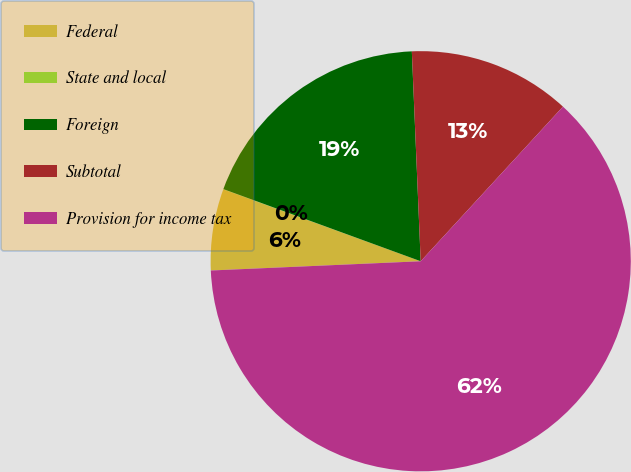Convert chart. <chart><loc_0><loc_0><loc_500><loc_500><pie_chart><fcel>Federal<fcel>State and local<fcel>Foreign<fcel>Subtotal<fcel>Provision for income tax<nl><fcel>6.26%<fcel>0.02%<fcel>18.75%<fcel>12.51%<fcel>62.46%<nl></chart> 